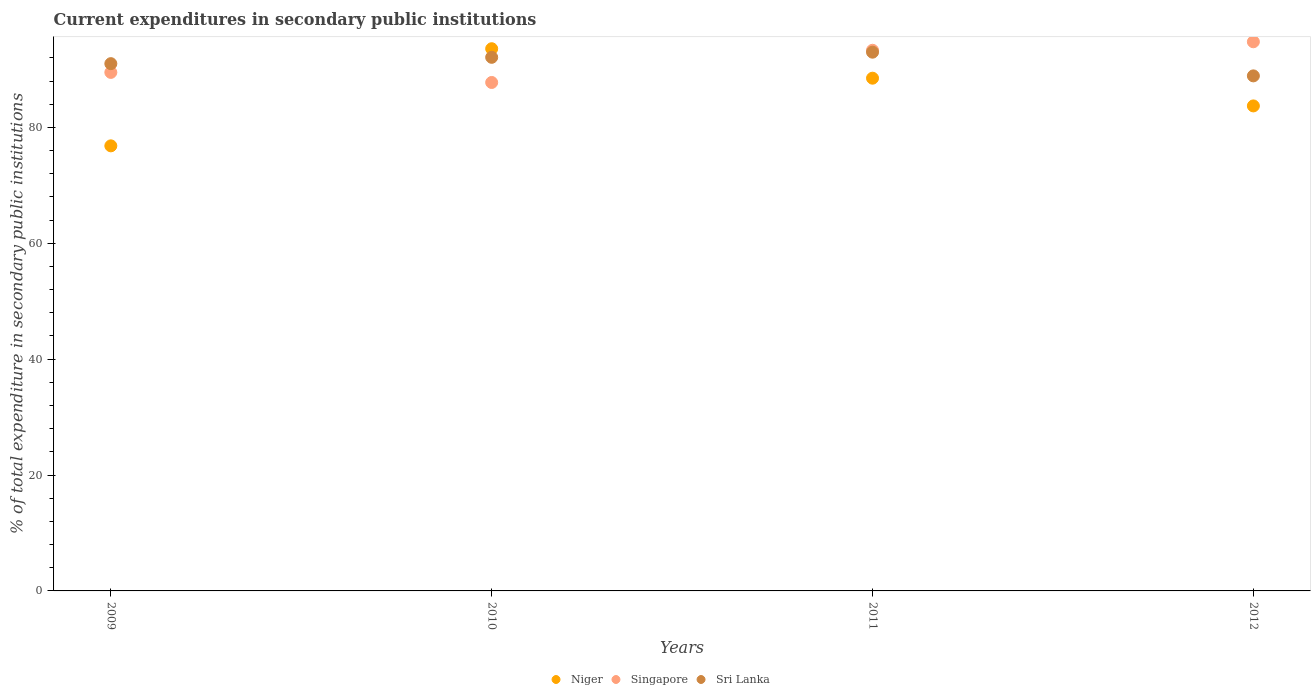How many different coloured dotlines are there?
Your answer should be compact. 3. Is the number of dotlines equal to the number of legend labels?
Offer a very short reply. Yes. What is the current expenditures in secondary public institutions in Niger in 2009?
Give a very brief answer. 76.82. Across all years, what is the maximum current expenditures in secondary public institutions in Singapore?
Your response must be concise. 94.78. Across all years, what is the minimum current expenditures in secondary public institutions in Singapore?
Provide a succinct answer. 87.75. What is the total current expenditures in secondary public institutions in Niger in the graph?
Keep it short and to the point. 342.6. What is the difference between the current expenditures in secondary public institutions in Niger in 2010 and that in 2011?
Provide a succinct answer. 5.09. What is the difference between the current expenditures in secondary public institutions in Sri Lanka in 2011 and the current expenditures in secondary public institutions in Singapore in 2010?
Your answer should be compact. 5.23. What is the average current expenditures in secondary public institutions in Singapore per year?
Give a very brief answer. 91.33. In the year 2011, what is the difference between the current expenditures in secondary public institutions in Niger and current expenditures in secondary public institutions in Sri Lanka?
Give a very brief answer. -4.49. In how many years, is the current expenditures in secondary public institutions in Niger greater than 44 %?
Provide a succinct answer. 4. What is the ratio of the current expenditures in secondary public institutions in Singapore in 2010 to that in 2011?
Your answer should be compact. 0.94. Is the difference between the current expenditures in secondary public institutions in Niger in 2009 and 2011 greater than the difference between the current expenditures in secondary public institutions in Sri Lanka in 2009 and 2011?
Provide a succinct answer. No. What is the difference between the highest and the second highest current expenditures in secondary public institutions in Singapore?
Provide a succinct answer. 1.47. What is the difference between the highest and the lowest current expenditures in secondary public institutions in Sri Lanka?
Offer a terse response. 4.09. In how many years, is the current expenditures in secondary public institutions in Niger greater than the average current expenditures in secondary public institutions in Niger taken over all years?
Provide a short and direct response. 2. Is it the case that in every year, the sum of the current expenditures in secondary public institutions in Sri Lanka and current expenditures in secondary public institutions in Singapore  is greater than the current expenditures in secondary public institutions in Niger?
Offer a terse response. Yes. Does the current expenditures in secondary public institutions in Sri Lanka monotonically increase over the years?
Provide a short and direct response. No. Is the current expenditures in secondary public institutions in Niger strictly greater than the current expenditures in secondary public institutions in Singapore over the years?
Provide a succinct answer. No. How many dotlines are there?
Your answer should be very brief. 3. Are the values on the major ticks of Y-axis written in scientific E-notation?
Keep it short and to the point. No. Does the graph contain any zero values?
Provide a succinct answer. No. What is the title of the graph?
Ensure brevity in your answer.  Current expenditures in secondary public institutions. What is the label or title of the Y-axis?
Your response must be concise. % of total expenditure in secondary public institutions. What is the % of total expenditure in secondary public institutions in Niger in 2009?
Your response must be concise. 76.82. What is the % of total expenditure in secondary public institutions in Singapore in 2009?
Provide a succinct answer. 89.49. What is the % of total expenditure in secondary public institutions in Sri Lanka in 2009?
Offer a terse response. 91. What is the % of total expenditure in secondary public institutions in Niger in 2010?
Offer a terse response. 93.58. What is the % of total expenditure in secondary public institutions of Singapore in 2010?
Provide a short and direct response. 87.75. What is the % of total expenditure in secondary public institutions in Sri Lanka in 2010?
Offer a very short reply. 92.09. What is the % of total expenditure in secondary public institutions of Niger in 2011?
Your answer should be very brief. 88.49. What is the % of total expenditure in secondary public institutions in Singapore in 2011?
Your answer should be very brief. 93.31. What is the % of total expenditure in secondary public institutions in Sri Lanka in 2011?
Give a very brief answer. 92.98. What is the % of total expenditure in secondary public institutions in Niger in 2012?
Provide a succinct answer. 83.71. What is the % of total expenditure in secondary public institutions of Singapore in 2012?
Your answer should be very brief. 94.78. What is the % of total expenditure in secondary public institutions in Sri Lanka in 2012?
Provide a succinct answer. 88.89. Across all years, what is the maximum % of total expenditure in secondary public institutions of Niger?
Provide a succinct answer. 93.58. Across all years, what is the maximum % of total expenditure in secondary public institutions in Singapore?
Ensure brevity in your answer.  94.78. Across all years, what is the maximum % of total expenditure in secondary public institutions in Sri Lanka?
Make the answer very short. 92.98. Across all years, what is the minimum % of total expenditure in secondary public institutions in Niger?
Offer a terse response. 76.82. Across all years, what is the minimum % of total expenditure in secondary public institutions in Singapore?
Your answer should be very brief. 87.75. Across all years, what is the minimum % of total expenditure in secondary public institutions in Sri Lanka?
Your answer should be compact. 88.89. What is the total % of total expenditure in secondary public institutions of Niger in the graph?
Your answer should be compact. 342.6. What is the total % of total expenditure in secondary public institutions of Singapore in the graph?
Your answer should be compact. 365.33. What is the total % of total expenditure in secondary public institutions of Sri Lanka in the graph?
Keep it short and to the point. 364.97. What is the difference between the % of total expenditure in secondary public institutions in Niger in 2009 and that in 2010?
Give a very brief answer. -16.76. What is the difference between the % of total expenditure in secondary public institutions in Singapore in 2009 and that in 2010?
Make the answer very short. 1.74. What is the difference between the % of total expenditure in secondary public institutions in Sri Lanka in 2009 and that in 2010?
Provide a short and direct response. -1.09. What is the difference between the % of total expenditure in secondary public institutions in Niger in 2009 and that in 2011?
Ensure brevity in your answer.  -11.68. What is the difference between the % of total expenditure in secondary public institutions of Singapore in 2009 and that in 2011?
Ensure brevity in your answer.  -3.82. What is the difference between the % of total expenditure in secondary public institutions in Sri Lanka in 2009 and that in 2011?
Offer a very short reply. -1.98. What is the difference between the % of total expenditure in secondary public institutions of Niger in 2009 and that in 2012?
Provide a succinct answer. -6.89. What is the difference between the % of total expenditure in secondary public institutions in Singapore in 2009 and that in 2012?
Your answer should be compact. -5.29. What is the difference between the % of total expenditure in secondary public institutions in Sri Lanka in 2009 and that in 2012?
Give a very brief answer. 2.11. What is the difference between the % of total expenditure in secondary public institutions in Niger in 2010 and that in 2011?
Your response must be concise. 5.09. What is the difference between the % of total expenditure in secondary public institutions in Singapore in 2010 and that in 2011?
Make the answer very short. -5.56. What is the difference between the % of total expenditure in secondary public institutions of Sri Lanka in 2010 and that in 2011?
Your response must be concise. -0.89. What is the difference between the % of total expenditure in secondary public institutions in Niger in 2010 and that in 2012?
Give a very brief answer. 9.87. What is the difference between the % of total expenditure in secondary public institutions of Singapore in 2010 and that in 2012?
Ensure brevity in your answer.  -7.02. What is the difference between the % of total expenditure in secondary public institutions in Sri Lanka in 2010 and that in 2012?
Provide a short and direct response. 3.2. What is the difference between the % of total expenditure in secondary public institutions of Niger in 2011 and that in 2012?
Your response must be concise. 4.79. What is the difference between the % of total expenditure in secondary public institutions of Singapore in 2011 and that in 2012?
Ensure brevity in your answer.  -1.47. What is the difference between the % of total expenditure in secondary public institutions in Sri Lanka in 2011 and that in 2012?
Your answer should be very brief. 4.09. What is the difference between the % of total expenditure in secondary public institutions in Niger in 2009 and the % of total expenditure in secondary public institutions in Singapore in 2010?
Offer a terse response. -10.94. What is the difference between the % of total expenditure in secondary public institutions in Niger in 2009 and the % of total expenditure in secondary public institutions in Sri Lanka in 2010?
Keep it short and to the point. -15.28. What is the difference between the % of total expenditure in secondary public institutions in Singapore in 2009 and the % of total expenditure in secondary public institutions in Sri Lanka in 2010?
Provide a succinct answer. -2.6. What is the difference between the % of total expenditure in secondary public institutions of Niger in 2009 and the % of total expenditure in secondary public institutions of Singapore in 2011?
Keep it short and to the point. -16.49. What is the difference between the % of total expenditure in secondary public institutions in Niger in 2009 and the % of total expenditure in secondary public institutions in Sri Lanka in 2011?
Make the answer very short. -16.17. What is the difference between the % of total expenditure in secondary public institutions in Singapore in 2009 and the % of total expenditure in secondary public institutions in Sri Lanka in 2011?
Keep it short and to the point. -3.49. What is the difference between the % of total expenditure in secondary public institutions in Niger in 2009 and the % of total expenditure in secondary public institutions in Singapore in 2012?
Provide a succinct answer. -17.96. What is the difference between the % of total expenditure in secondary public institutions of Niger in 2009 and the % of total expenditure in secondary public institutions of Sri Lanka in 2012?
Give a very brief answer. -12.08. What is the difference between the % of total expenditure in secondary public institutions in Singapore in 2009 and the % of total expenditure in secondary public institutions in Sri Lanka in 2012?
Your response must be concise. 0.6. What is the difference between the % of total expenditure in secondary public institutions in Niger in 2010 and the % of total expenditure in secondary public institutions in Singapore in 2011?
Give a very brief answer. 0.27. What is the difference between the % of total expenditure in secondary public institutions of Niger in 2010 and the % of total expenditure in secondary public institutions of Sri Lanka in 2011?
Your answer should be compact. 0.6. What is the difference between the % of total expenditure in secondary public institutions in Singapore in 2010 and the % of total expenditure in secondary public institutions in Sri Lanka in 2011?
Provide a short and direct response. -5.23. What is the difference between the % of total expenditure in secondary public institutions of Niger in 2010 and the % of total expenditure in secondary public institutions of Singapore in 2012?
Your response must be concise. -1.2. What is the difference between the % of total expenditure in secondary public institutions in Niger in 2010 and the % of total expenditure in secondary public institutions in Sri Lanka in 2012?
Give a very brief answer. 4.69. What is the difference between the % of total expenditure in secondary public institutions in Singapore in 2010 and the % of total expenditure in secondary public institutions in Sri Lanka in 2012?
Give a very brief answer. -1.14. What is the difference between the % of total expenditure in secondary public institutions in Niger in 2011 and the % of total expenditure in secondary public institutions in Singapore in 2012?
Provide a short and direct response. -6.28. What is the difference between the % of total expenditure in secondary public institutions in Niger in 2011 and the % of total expenditure in secondary public institutions in Sri Lanka in 2012?
Your answer should be very brief. -0.4. What is the difference between the % of total expenditure in secondary public institutions in Singapore in 2011 and the % of total expenditure in secondary public institutions in Sri Lanka in 2012?
Provide a succinct answer. 4.42. What is the average % of total expenditure in secondary public institutions in Niger per year?
Your response must be concise. 85.65. What is the average % of total expenditure in secondary public institutions in Singapore per year?
Provide a short and direct response. 91.33. What is the average % of total expenditure in secondary public institutions of Sri Lanka per year?
Your answer should be compact. 91.24. In the year 2009, what is the difference between the % of total expenditure in secondary public institutions in Niger and % of total expenditure in secondary public institutions in Singapore?
Provide a short and direct response. -12.68. In the year 2009, what is the difference between the % of total expenditure in secondary public institutions of Niger and % of total expenditure in secondary public institutions of Sri Lanka?
Provide a short and direct response. -14.19. In the year 2009, what is the difference between the % of total expenditure in secondary public institutions in Singapore and % of total expenditure in secondary public institutions in Sri Lanka?
Offer a very short reply. -1.51. In the year 2010, what is the difference between the % of total expenditure in secondary public institutions of Niger and % of total expenditure in secondary public institutions of Singapore?
Your answer should be very brief. 5.83. In the year 2010, what is the difference between the % of total expenditure in secondary public institutions in Niger and % of total expenditure in secondary public institutions in Sri Lanka?
Offer a terse response. 1.48. In the year 2010, what is the difference between the % of total expenditure in secondary public institutions of Singapore and % of total expenditure in secondary public institutions of Sri Lanka?
Provide a short and direct response. -4.34. In the year 2011, what is the difference between the % of total expenditure in secondary public institutions in Niger and % of total expenditure in secondary public institutions in Singapore?
Provide a succinct answer. -4.82. In the year 2011, what is the difference between the % of total expenditure in secondary public institutions of Niger and % of total expenditure in secondary public institutions of Sri Lanka?
Offer a terse response. -4.49. In the year 2011, what is the difference between the % of total expenditure in secondary public institutions in Singapore and % of total expenditure in secondary public institutions in Sri Lanka?
Give a very brief answer. 0.33. In the year 2012, what is the difference between the % of total expenditure in secondary public institutions in Niger and % of total expenditure in secondary public institutions in Singapore?
Provide a short and direct response. -11.07. In the year 2012, what is the difference between the % of total expenditure in secondary public institutions of Niger and % of total expenditure in secondary public institutions of Sri Lanka?
Your answer should be very brief. -5.18. In the year 2012, what is the difference between the % of total expenditure in secondary public institutions in Singapore and % of total expenditure in secondary public institutions in Sri Lanka?
Your answer should be very brief. 5.89. What is the ratio of the % of total expenditure in secondary public institutions in Niger in 2009 to that in 2010?
Ensure brevity in your answer.  0.82. What is the ratio of the % of total expenditure in secondary public institutions in Singapore in 2009 to that in 2010?
Your response must be concise. 1.02. What is the ratio of the % of total expenditure in secondary public institutions in Niger in 2009 to that in 2011?
Your answer should be very brief. 0.87. What is the ratio of the % of total expenditure in secondary public institutions of Singapore in 2009 to that in 2011?
Provide a succinct answer. 0.96. What is the ratio of the % of total expenditure in secondary public institutions of Sri Lanka in 2009 to that in 2011?
Your answer should be very brief. 0.98. What is the ratio of the % of total expenditure in secondary public institutions of Niger in 2009 to that in 2012?
Your response must be concise. 0.92. What is the ratio of the % of total expenditure in secondary public institutions of Singapore in 2009 to that in 2012?
Provide a succinct answer. 0.94. What is the ratio of the % of total expenditure in secondary public institutions of Sri Lanka in 2009 to that in 2012?
Give a very brief answer. 1.02. What is the ratio of the % of total expenditure in secondary public institutions in Niger in 2010 to that in 2011?
Your answer should be compact. 1.06. What is the ratio of the % of total expenditure in secondary public institutions of Singapore in 2010 to that in 2011?
Make the answer very short. 0.94. What is the ratio of the % of total expenditure in secondary public institutions of Sri Lanka in 2010 to that in 2011?
Your response must be concise. 0.99. What is the ratio of the % of total expenditure in secondary public institutions in Niger in 2010 to that in 2012?
Provide a short and direct response. 1.12. What is the ratio of the % of total expenditure in secondary public institutions of Singapore in 2010 to that in 2012?
Offer a very short reply. 0.93. What is the ratio of the % of total expenditure in secondary public institutions of Sri Lanka in 2010 to that in 2012?
Provide a short and direct response. 1.04. What is the ratio of the % of total expenditure in secondary public institutions of Niger in 2011 to that in 2012?
Your answer should be very brief. 1.06. What is the ratio of the % of total expenditure in secondary public institutions in Singapore in 2011 to that in 2012?
Ensure brevity in your answer.  0.98. What is the ratio of the % of total expenditure in secondary public institutions in Sri Lanka in 2011 to that in 2012?
Offer a terse response. 1.05. What is the difference between the highest and the second highest % of total expenditure in secondary public institutions of Niger?
Make the answer very short. 5.09. What is the difference between the highest and the second highest % of total expenditure in secondary public institutions of Singapore?
Offer a terse response. 1.47. What is the difference between the highest and the second highest % of total expenditure in secondary public institutions in Sri Lanka?
Ensure brevity in your answer.  0.89. What is the difference between the highest and the lowest % of total expenditure in secondary public institutions of Niger?
Offer a terse response. 16.76. What is the difference between the highest and the lowest % of total expenditure in secondary public institutions in Singapore?
Your answer should be very brief. 7.02. What is the difference between the highest and the lowest % of total expenditure in secondary public institutions of Sri Lanka?
Ensure brevity in your answer.  4.09. 